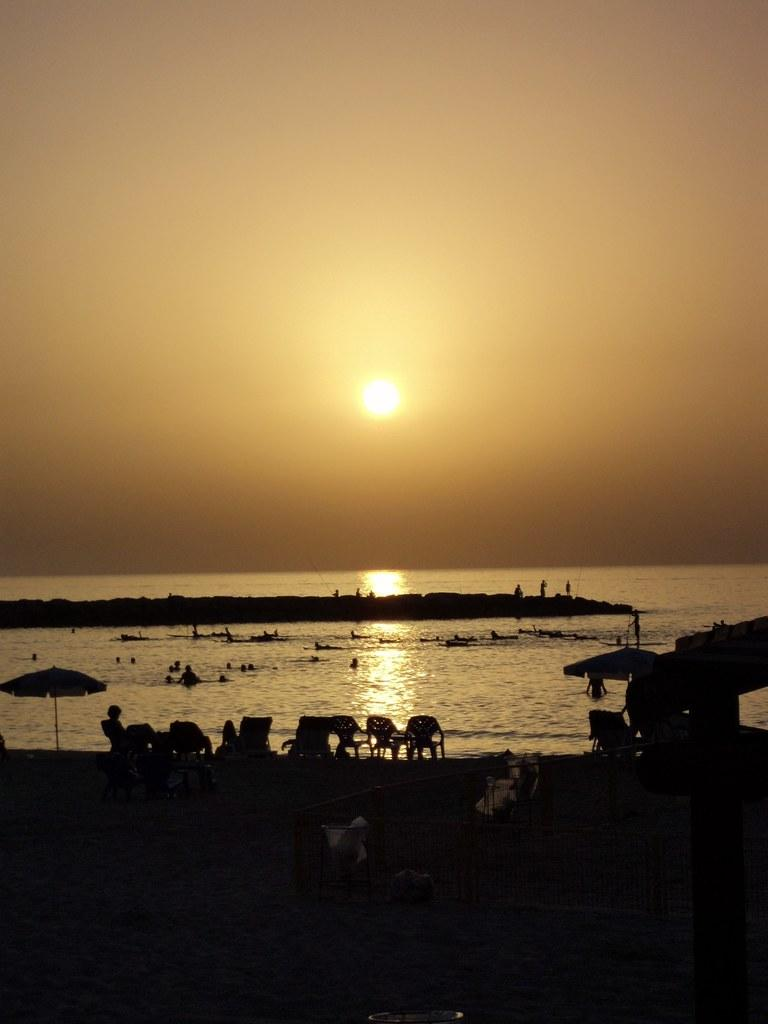At what time of day was the image taken? The image was taken during sunset. What can be seen in the sky during this time? The sun is visible in the sky. What is the main subject in the center of the image? There is water and rock in the center of the image. What objects are present in the foreground? There are chairs, umbrellas, and people in the foreground. Are there any bears visible in the image? No, there are no bears present in the image. What game are the people in the foreground playing? There is no game being played in the image; the people are simply standing or sitting in the foreground. 